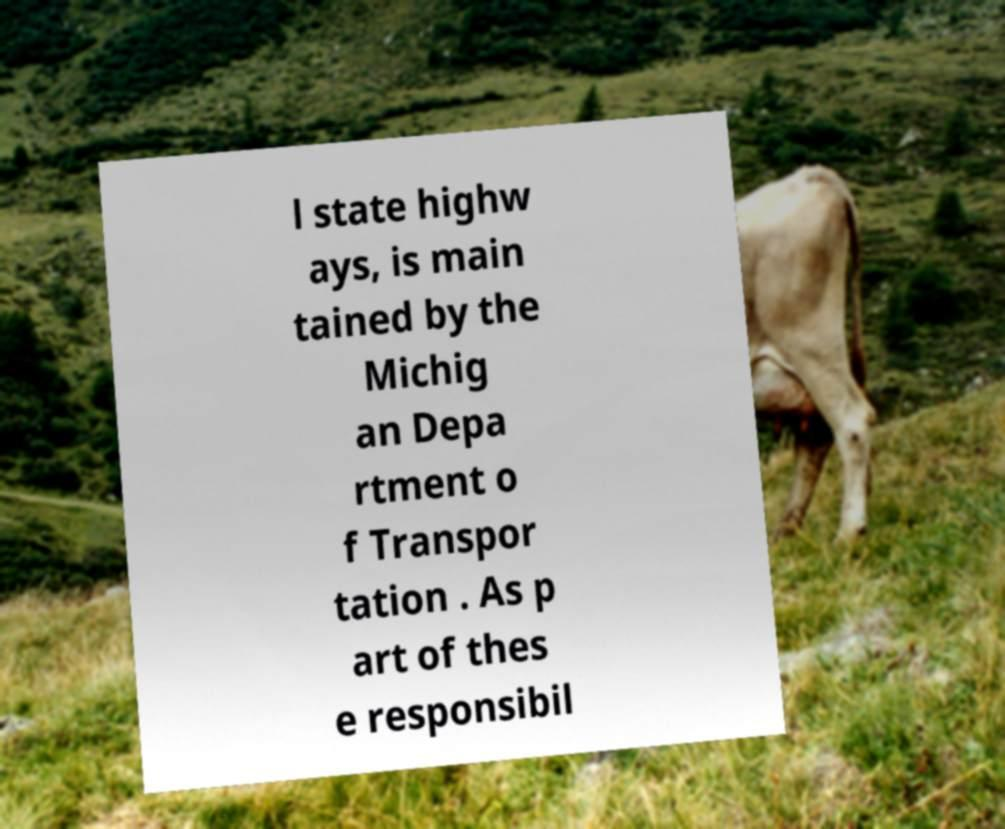Please identify and transcribe the text found in this image. l state highw ays, is main tained by the Michig an Depa rtment o f Transpor tation . As p art of thes e responsibil 